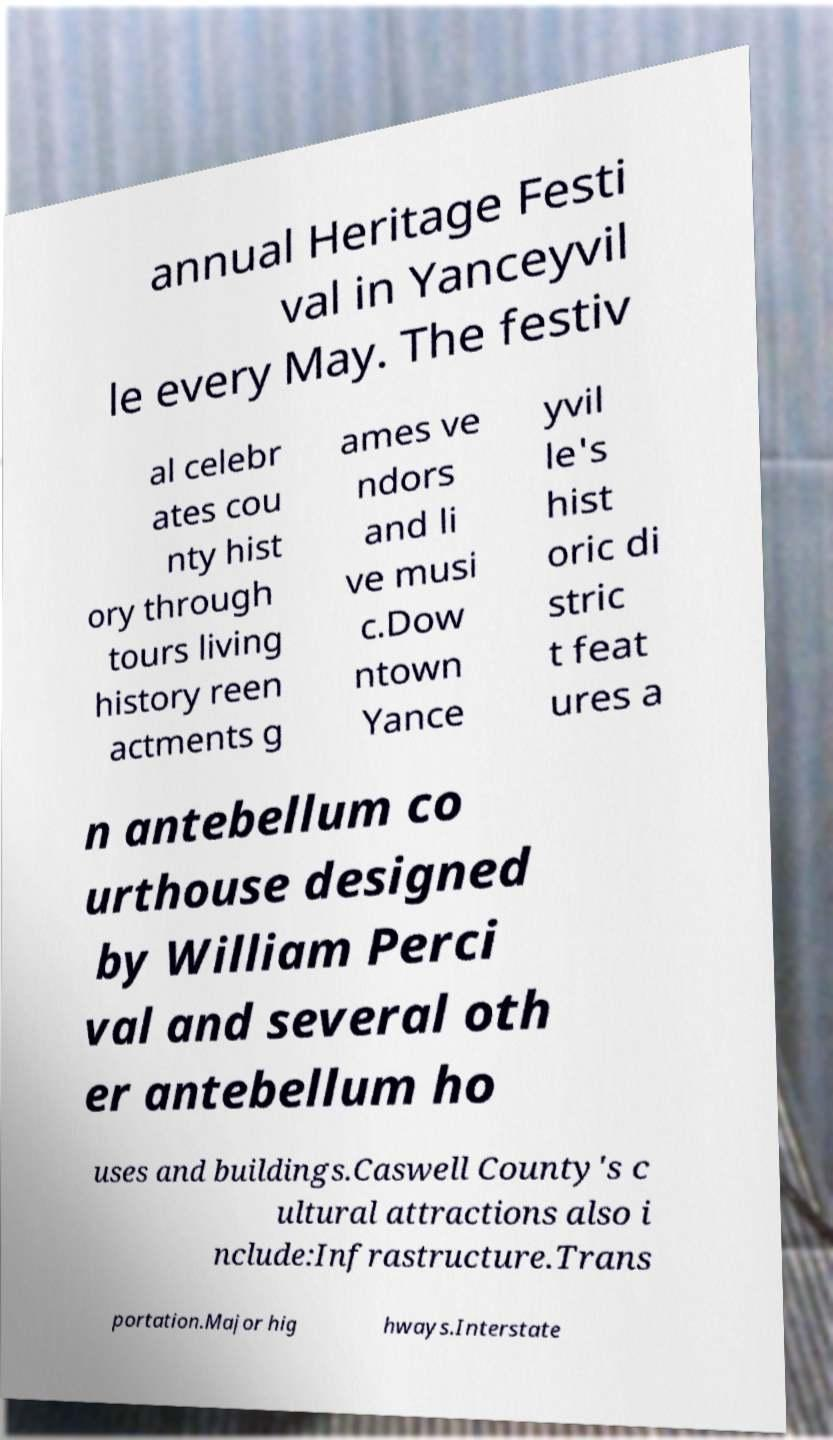Can you accurately transcribe the text from the provided image for me? annual Heritage Festi val in Yanceyvil le every May. The festiv al celebr ates cou nty hist ory through tours living history reen actments g ames ve ndors and li ve musi c.Dow ntown Yance yvil le's hist oric di stric t feat ures a n antebellum co urthouse designed by William Perci val and several oth er antebellum ho uses and buildings.Caswell County's c ultural attractions also i nclude:Infrastructure.Trans portation.Major hig hways.Interstate 